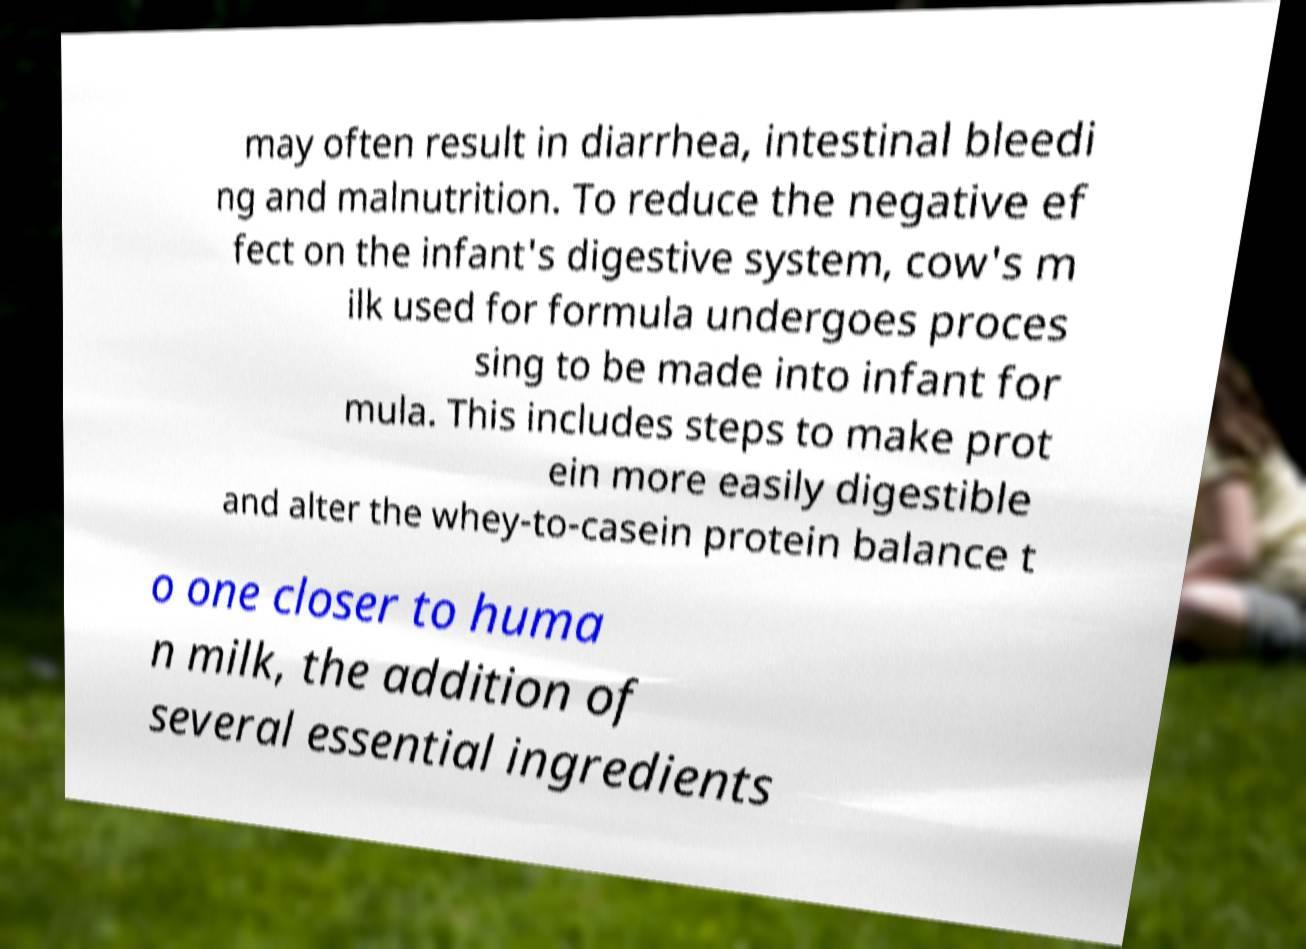Can you read and provide the text displayed in the image?This photo seems to have some interesting text. Can you extract and type it out for me? may often result in diarrhea, intestinal bleedi ng and malnutrition. To reduce the negative ef fect on the infant's digestive system, cow's m ilk used for formula undergoes proces sing to be made into infant for mula. This includes steps to make prot ein more easily digestible and alter the whey-to-casein protein balance t o one closer to huma n milk, the addition of several essential ingredients 